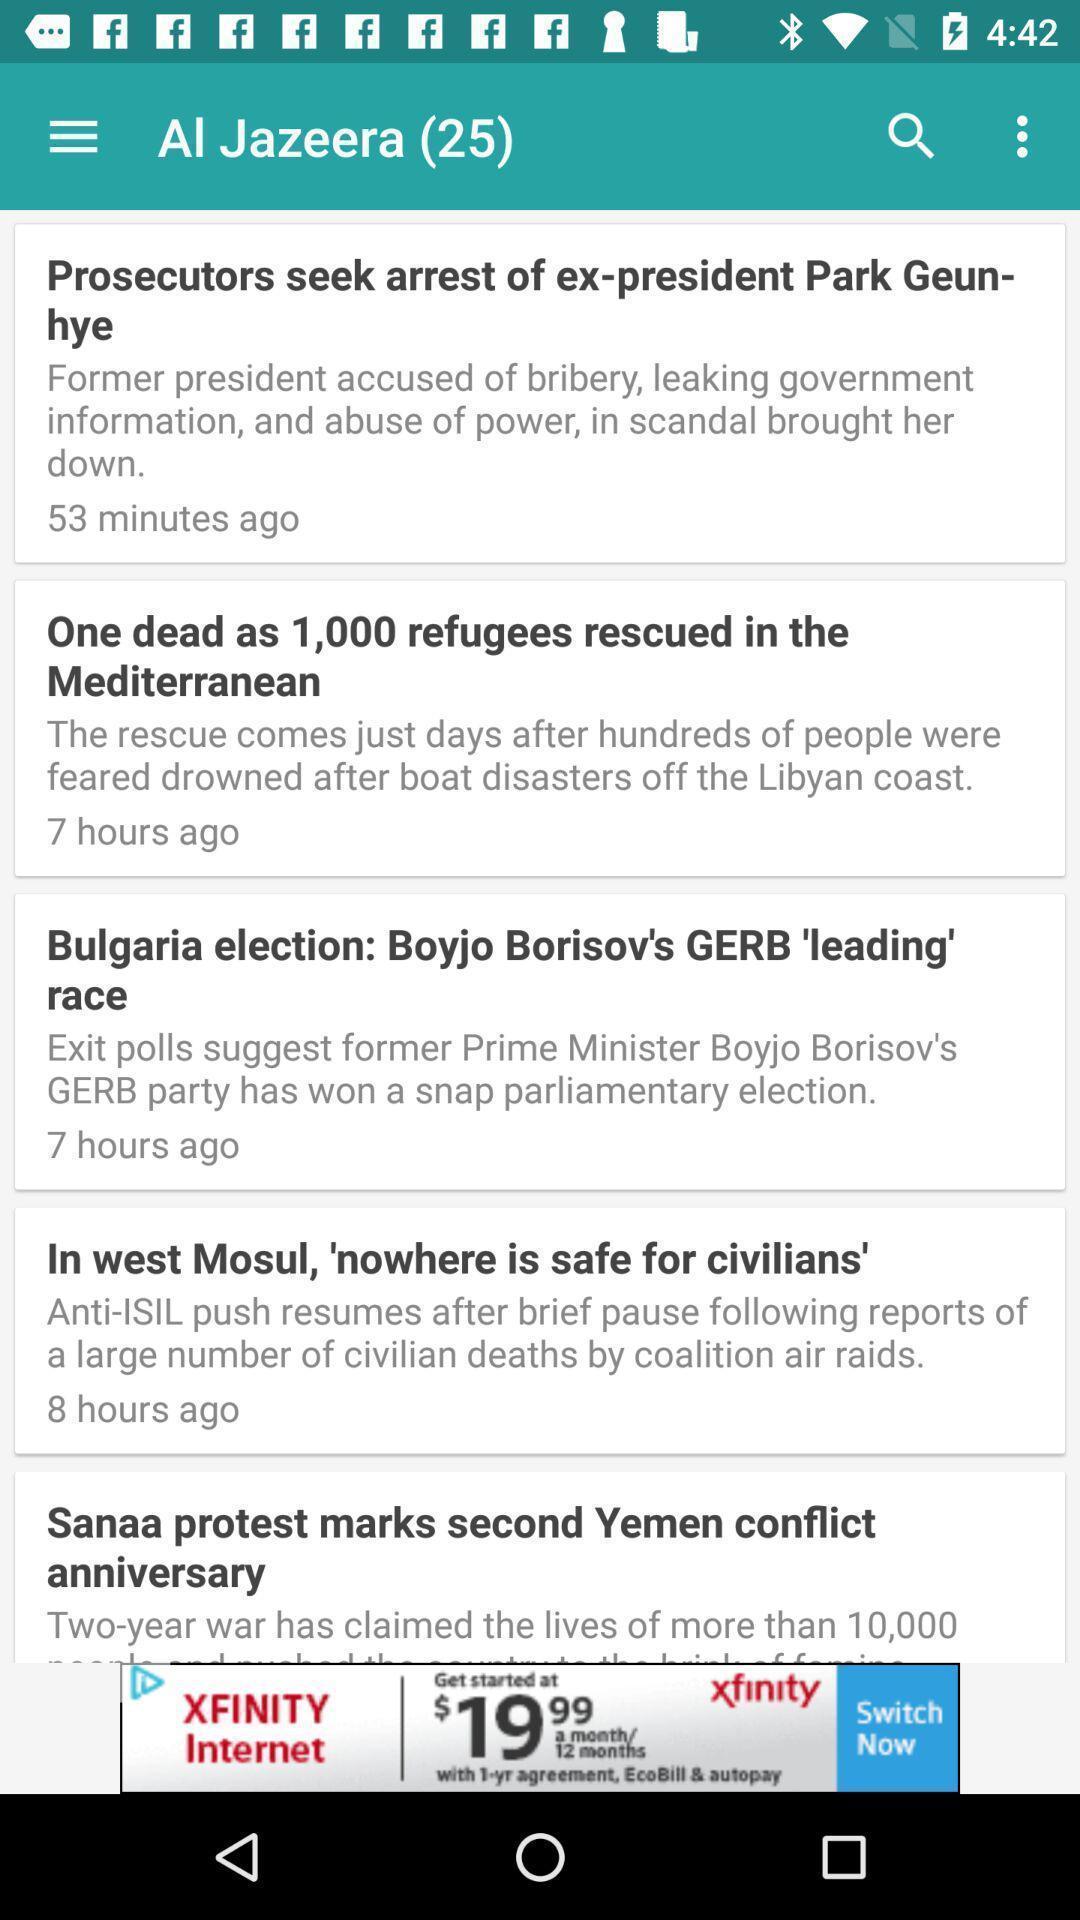Give me a narrative description of this picture. Screen displaying list of news articles. 